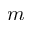Convert formula to latex. <formula><loc_0><loc_0><loc_500><loc_500>m</formula> 